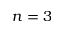<formula> <loc_0><loc_0><loc_500><loc_500>n = 3</formula> 